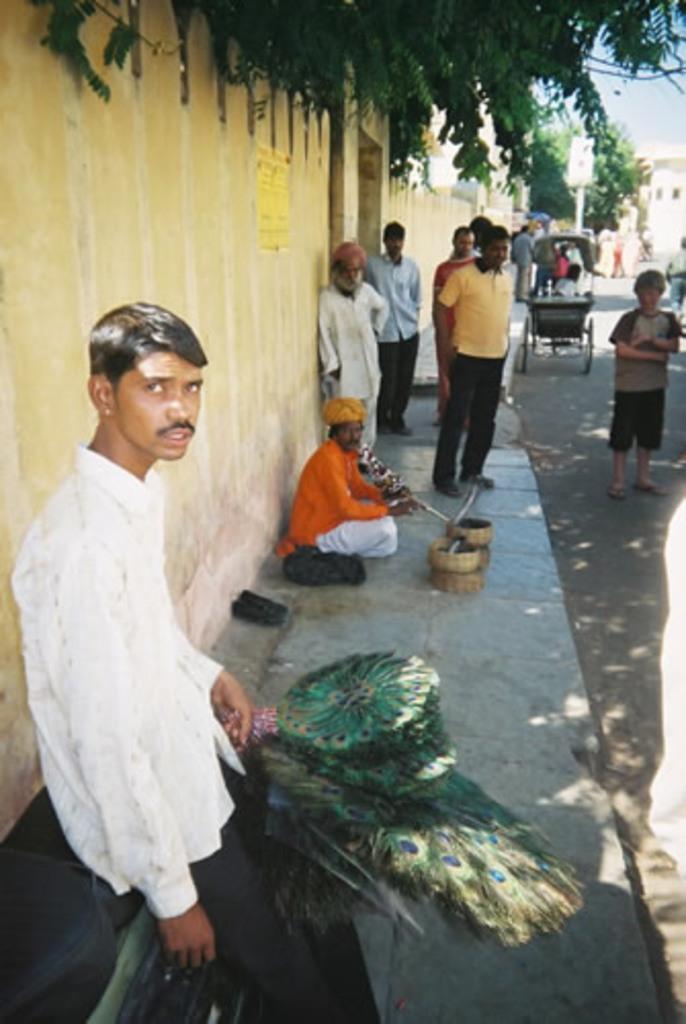Can you describe this image briefly? As we can see in the image there is a wall, trees, vehicle, basket and few people here and there. 